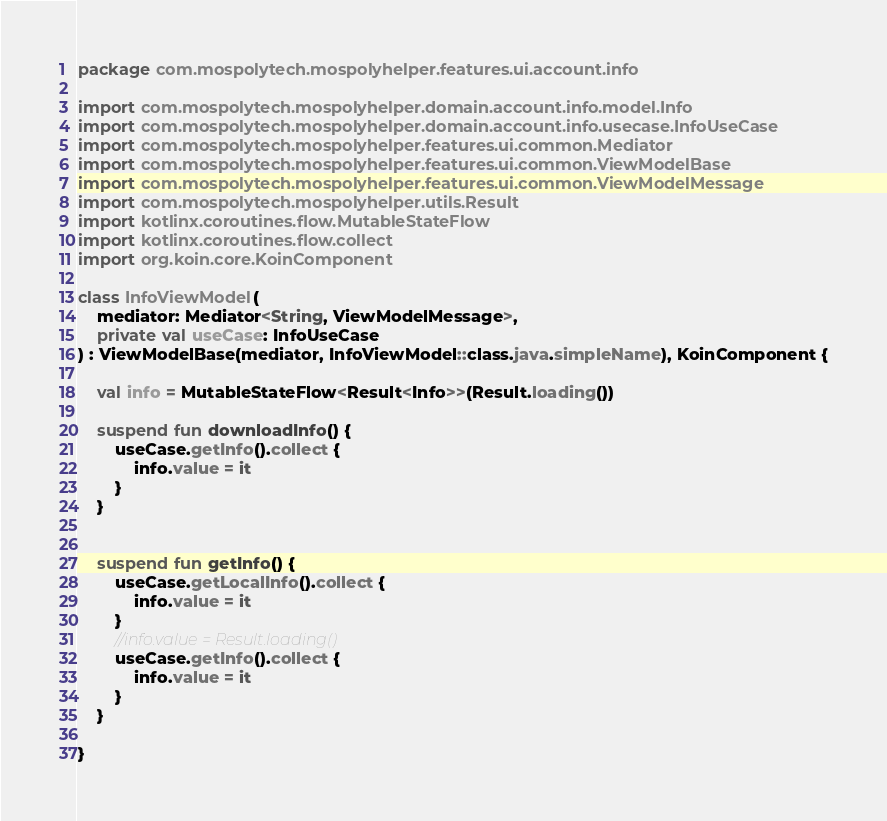<code> <loc_0><loc_0><loc_500><loc_500><_Kotlin_>package com.mospolytech.mospolyhelper.features.ui.account.info

import com.mospolytech.mospolyhelper.domain.account.info.model.Info
import com.mospolytech.mospolyhelper.domain.account.info.usecase.InfoUseCase
import com.mospolytech.mospolyhelper.features.ui.common.Mediator
import com.mospolytech.mospolyhelper.features.ui.common.ViewModelBase
import com.mospolytech.mospolyhelper.features.ui.common.ViewModelMessage
import com.mospolytech.mospolyhelper.utils.Result
import kotlinx.coroutines.flow.MutableStateFlow
import kotlinx.coroutines.flow.collect
import org.koin.core.KoinComponent

class InfoViewModel(
    mediator: Mediator<String, ViewModelMessage>,
    private val useCase: InfoUseCase
) : ViewModelBase(mediator, InfoViewModel::class.java.simpleName), KoinComponent {

    val info = MutableStateFlow<Result<Info>>(Result.loading())

    suspend fun downloadInfo() {
        useCase.getInfo().collect {
            info.value = it
        }
    }


    suspend fun getInfo() {
        useCase.getLocalInfo().collect {
            info.value = it
        }
        //info.value = Result.loading()
        useCase.getInfo().collect {
            info.value = it
        }
    }

}</code> 